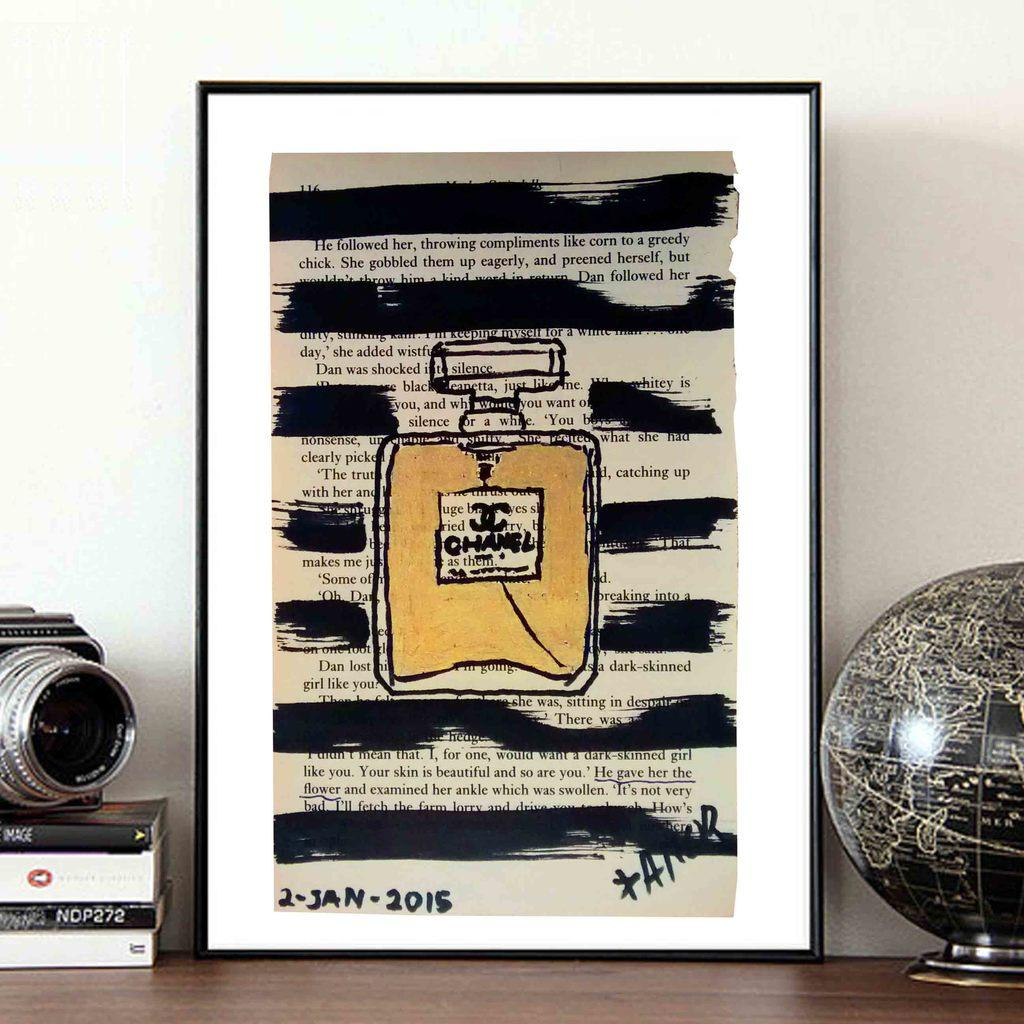What is on the poster in the image? There is a note on the poster in the image. What object in the image represents the Earth? There is a globe in the image that represents the Earth. What is the camera positioned on in the image? The camera is on the books in the image. What piece of furniture is present in the image? There is a table in the image. What type of structure is visible in the background of the image? There is a wall in the image. How many suns are visible in the image? There are no suns visible in the image. What type of nut is being used as a paperweight on the note? There is no nut present in the image; the note is on a poster. 